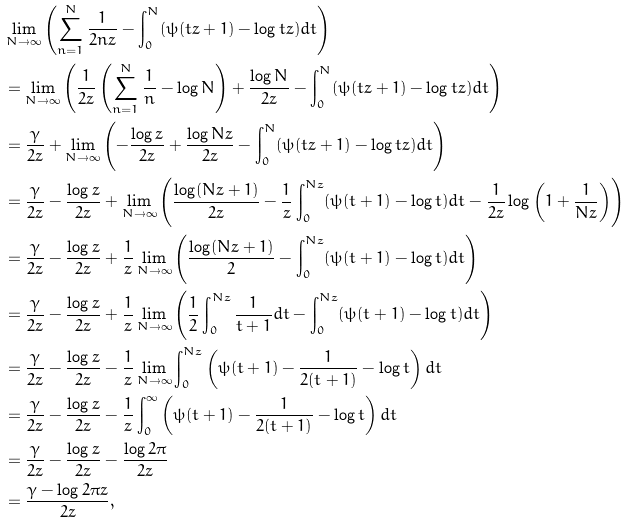<formula> <loc_0><loc_0><loc_500><loc_500>& \lim _ { N \to \infty } \left ( \sum _ { n = 1 } ^ { N } \frac { 1 } { 2 n z } - \int _ { 0 } ^ { N } ( \psi ( t z + 1 ) - \log t z ) d t \right ) \\ & = \lim _ { N \to \infty } \left ( \frac { 1 } { 2 z } \left ( \sum _ { n = 1 } ^ { N } \frac { 1 } { n } - \log N \right ) + \frac { \log N } { 2 z } - \int _ { 0 } ^ { N } ( \psi ( t z + 1 ) - \log t z ) d t \right ) \\ & = \frac { \gamma } { 2 z } + \lim _ { N \to \infty } \left ( - \frac { \log z } { 2 z } + \frac { \log N z } { 2 z } - \int _ { 0 } ^ { N } ( \psi ( t z + 1 ) - \log t z ) d t \right ) \\ & = \frac { \gamma } { 2 z } - \frac { \log z } { 2 z } + \lim _ { N \to \infty } \left ( \frac { \log ( N z + 1 ) } { 2 z } - \frac { 1 } { z } \int _ { 0 } ^ { N z } ( \psi ( t + 1 ) - \log t ) d t - \frac { 1 } { 2 z } \log \left ( 1 + \frac { 1 } { N z } \right ) \right ) \\ & = \frac { \gamma } { 2 z } - \frac { \log z } { 2 z } + \frac { 1 } { z } \lim _ { N \to \infty } \left ( \frac { \log ( N z + 1 ) } { 2 } - \int _ { 0 } ^ { N z } ( \psi ( t + 1 ) - \log t ) d t \right ) \\ & = \frac { \gamma } { 2 z } - \frac { \log z } { 2 z } + \frac { 1 } { z } \lim _ { N \to \infty } \left ( \frac { 1 } { 2 } \int _ { 0 } ^ { N z } \frac { 1 } { t + 1 } d t - \int _ { 0 } ^ { N z } ( \psi ( t + 1 ) - \log t ) d t \right ) \\ & = \frac { \gamma } { 2 z } - \frac { \log z } { 2 z } - \frac { 1 } { z } \lim _ { N \to \infty } \int _ { 0 } ^ { N z } \left ( \psi ( t + 1 ) - \frac { 1 } { 2 ( t + 1 ) } - \log t \right ) d t \\ & = \frac { \gamma } { 2 z } - \frac { \log z } { 2 z } - \frac { 1 } { z } \int _ { 0 } ^ { \infty } \left ( \psi ( t + 1 ) - \frac { 1 } { 2 ( t + 1 ) } - \log t \right ) d t \\ & = \frac { \gamma } { 2 z } - \frac { \log z } { 2 z } - \frac { \log 2 \pi } { 2 z } \\ & = \frac { \gamma - \log 2 \pi z } { 2 z } ,</formula> 